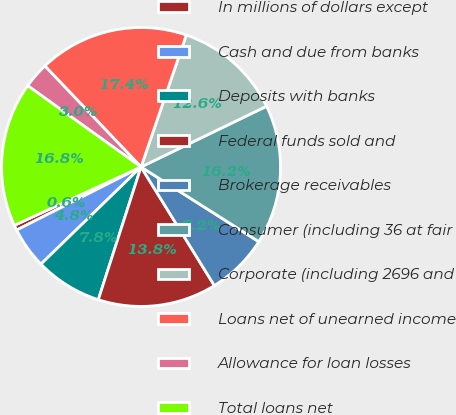Convert chart to OTSL. <chart><loc_0><loc_0><loc_500><loc_500><pie_chart><fcel>In millions of dollars except<fcel>Cash and due from banks<fcel>Deposits with banks<fcel>Federal funds sold and<fcel>Brokerage receivables<fcel>Consumer (including 36 at fair<fcel>Corporate (including 2696 and<fcel>Loans net of unearned income<fcel>Allowance for loan losses<fcel>Total loans net<nl><fcel>0.6%<fcel>4.79%<fcel>7.78%<fcel>13.77%<fcel>7.19%<fcel>16.17%<fcel>12.57%<fcel>17.37%<fcel>2.99%<fcel>16.77%<nl></chart> 